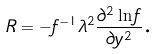<formula> <loc_0><loc_0><loc_500><loc_500>R = - f ^ { - 1 } \lambda ^ { 2 } \frac { \partial ^ { 2 } \ln f } { \partial y ^ { 2 } } \text {.}</formula> 